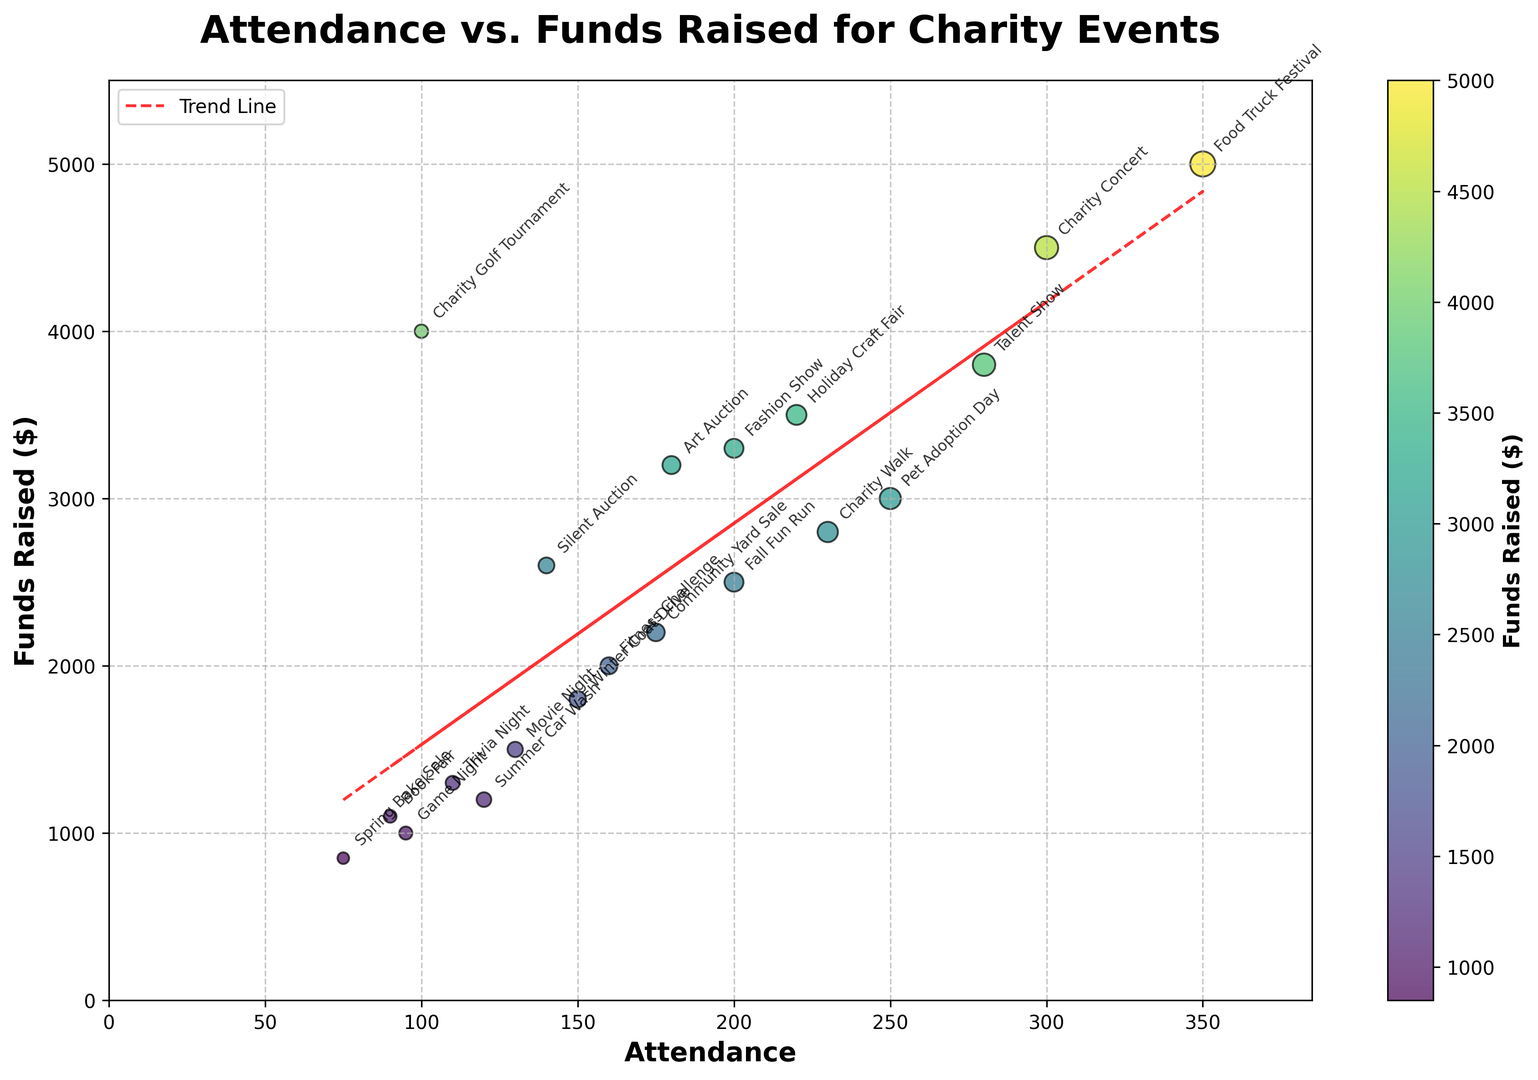What is the trend line showing in the scatter plot? The trend line, represented in red dashes, shows the positive relationship between attendance and funds raised. As attendance increases, the funds raised also tend to increase, suggesting that more attendees generally lead to higher funds raised.
Answer: Positive relationship between attendance and funds raised Which event has the highest attendance, and how much funds did it raise? The event with the highest attendance is the Food Truck Festival, with 350 attendees. It raised $5000. This can be observed by identifying the event at the highest point along the attendance axis.
Answer: Food Truck Festival, $5000 Is there any event with higher funds raised but lower attendance compared to the Charity Concert? Yes, the Charity Golf Tournament raised more funds ($4000) but had lower attendance (100) compared to the Charity Concert, which raised $4500 and had 300 attendees. This can be noticed by comparing the attendance and funds raised for both events on the scatter plot.
Answer: Charity Golf Tournament How much did the Fall Fun Run raise, and what was its attendance? The Fall Fun Run had an attendance of 200 and raised $2500. This information can be noted from the scatter plot annotations and their corresponding locations on the plot.
Answer: $2500, 200 attendees What is the average amount of funds raised by events with an attendance of over 200? There are seven events with attendance over 200: Holiday Craft Fair, Talent Show, Food Truck Festival, Charity Walk, Trivia Night, Charity Concert, and Pet Adoption Day. Their funds raised are: $3500, $3800, $5000, $2800, $1300, $4500, and $3000 respectively. Summing these values gives $23900, and dividing by 7 gives an average of approximately $3414.
Answer: $3414 Which events raised more than $3000? The events that raised more than $3000 are Art Auction ($3200), Charity Concert ($4500), Holiday Craft Fair ($3500), Talent Show ($3800), Food Truck Festival ($5000), Fashion Show ($3300), and Charity Golf Tournament ($4000). These values can be directly seen by looking above $3000 on the funds raised axis and noting the events.
Answer: Art Auction, Charity Concert, Holiday Craft Fair, Talent Show, Food Truck Festival, Fashion Show, Charity Golf Tournament What color are the dots for the events that raised between $1000 and $2000? The dots for events raising between $1000 and $2000 are primarily green, as seen in the scatter plot. These dots usually fall into the green part of the colormap used for funds raised.
Answer: Green Is the Attendance axis or Funds Raised axis longer, and what is their approximate range? The Attendance axis is longer, ranging approximately from 0 to around 385, while the Funds Raised axis ranges from 0 to around 5500. This can be observed by the x and y-axis limits provided on the scatter plot.
Answer: Attendance axis, 0-385 for Attendance and 0-5500 for Funds Raised 